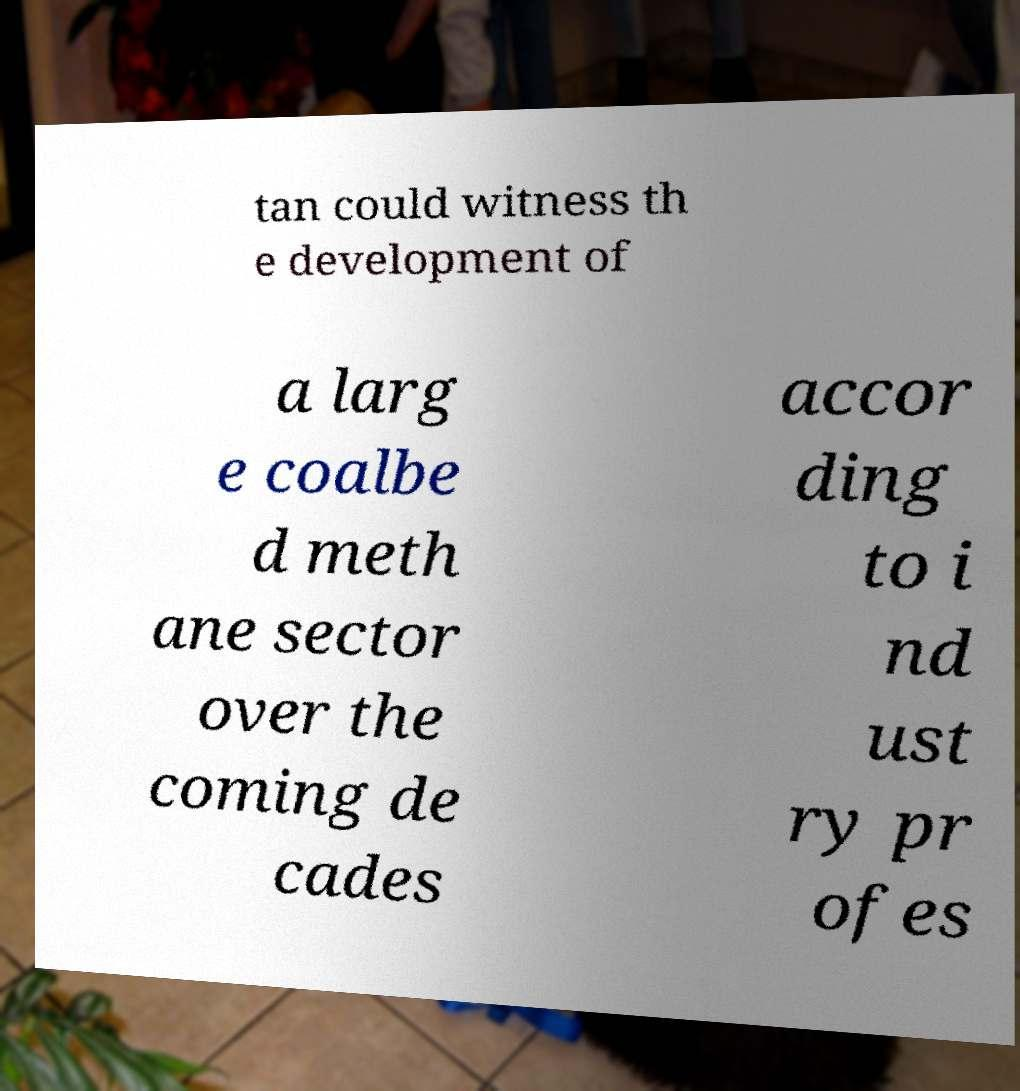Please read and relay the text visible in this image. What does it say? tan could witness th e development of a larg e coalbe d meth ane sector over the coming de cades accor ding to i nd ust ry pr ofes 